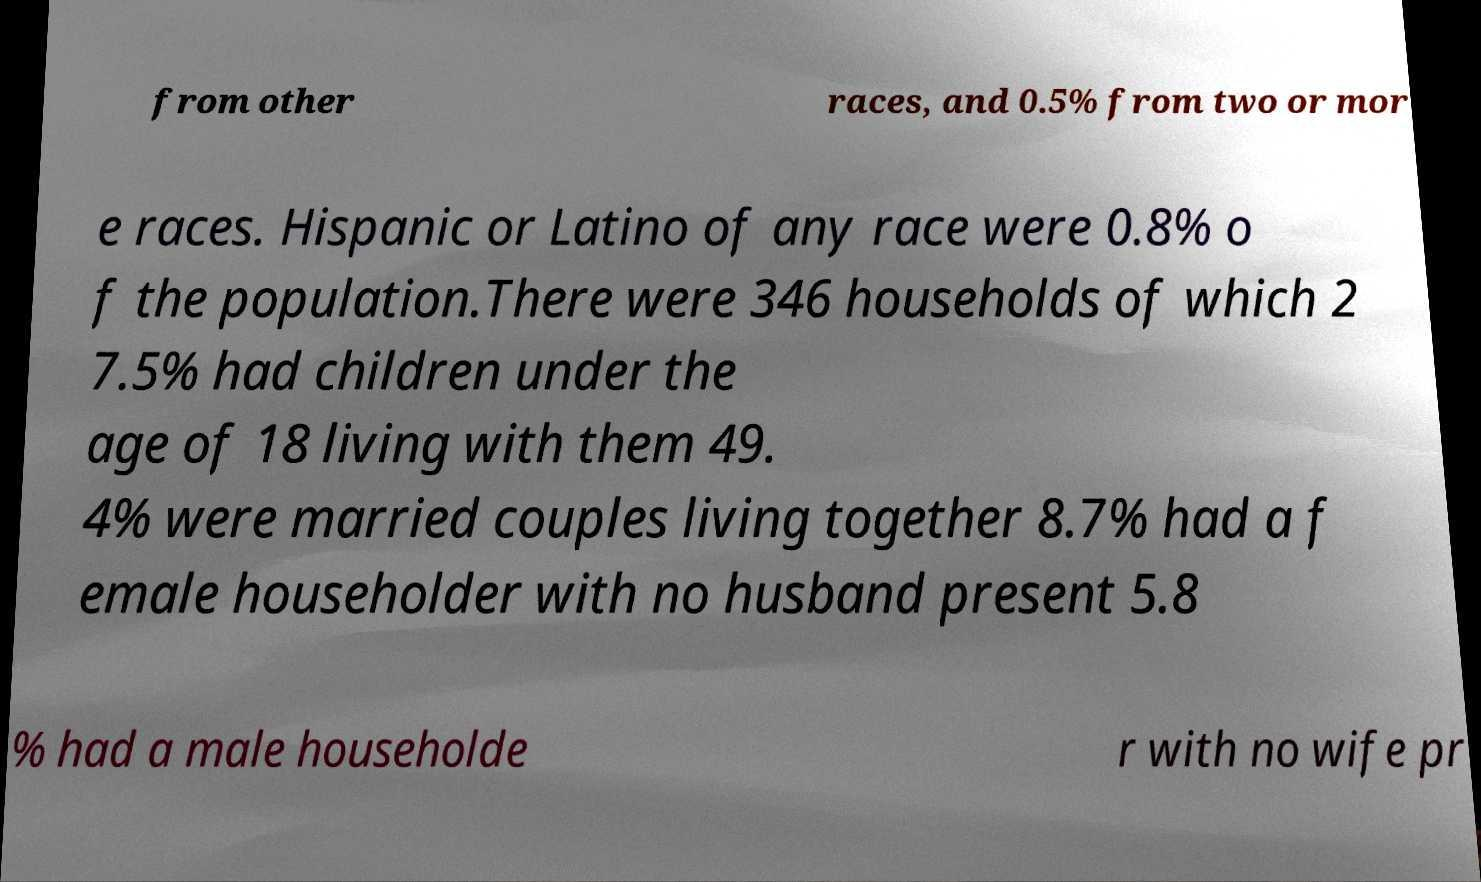Can you read and provide the text displayed in the image?This photo seems to have some interesting text. Can you extract and type it out for me? from other races, and 0.5% from two or mor e races. Hispanic or Latino of any race were 0.8% o f the population.There were 346 households of which 2 7.5% had children under the age of 18 living with them 49. 4% were married couples living together 8.7% had a f emale householder with no husband present 5.8 % had a male householde r with no wife pr 